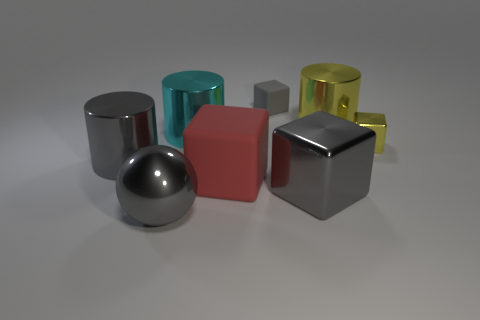Does the gray shiny thing right of the gray rubber object have the same shape as the tiny metal object in front of the tiny gray matte block?
Your response must be concise. Yes. There is a object that is to the left of the cyan object and behind the gray metallic sphere; what color is it?
Provide a short and direct response. Gray. There is a sphere; is its color the same as the small object that is to the left of the small yellow metal cube?
Provide a short and direct response. Yes. There is a gray thing that is both to the left of the big matte block and to the right of the large gray cylinder; what is its size?
Your answer should be compact. Large. How many other things are there of the same color as the big rubber thing?
Give a very brief answer. 0. There is a yellow thing to the right of the cylinder that is on the right side of the rubber block that is behind the small shiny cube; how big is it?
Provide a succinct answer. Small. There is a large gray sphere; are there any red objects left of it?
Keep it short and to the point. No. There is a yellow shiny cylinder; is its size the same as the shiny cube behind the gray metal cylinder?
Provide a succinct answer. No. How many other objects are the same material as the red block?
Give a very brief answer. 1. What shape is the object that is to the left of the yellow metallic cylinder and behind the cyan metal thing?
Offer a terse response. Cube. 